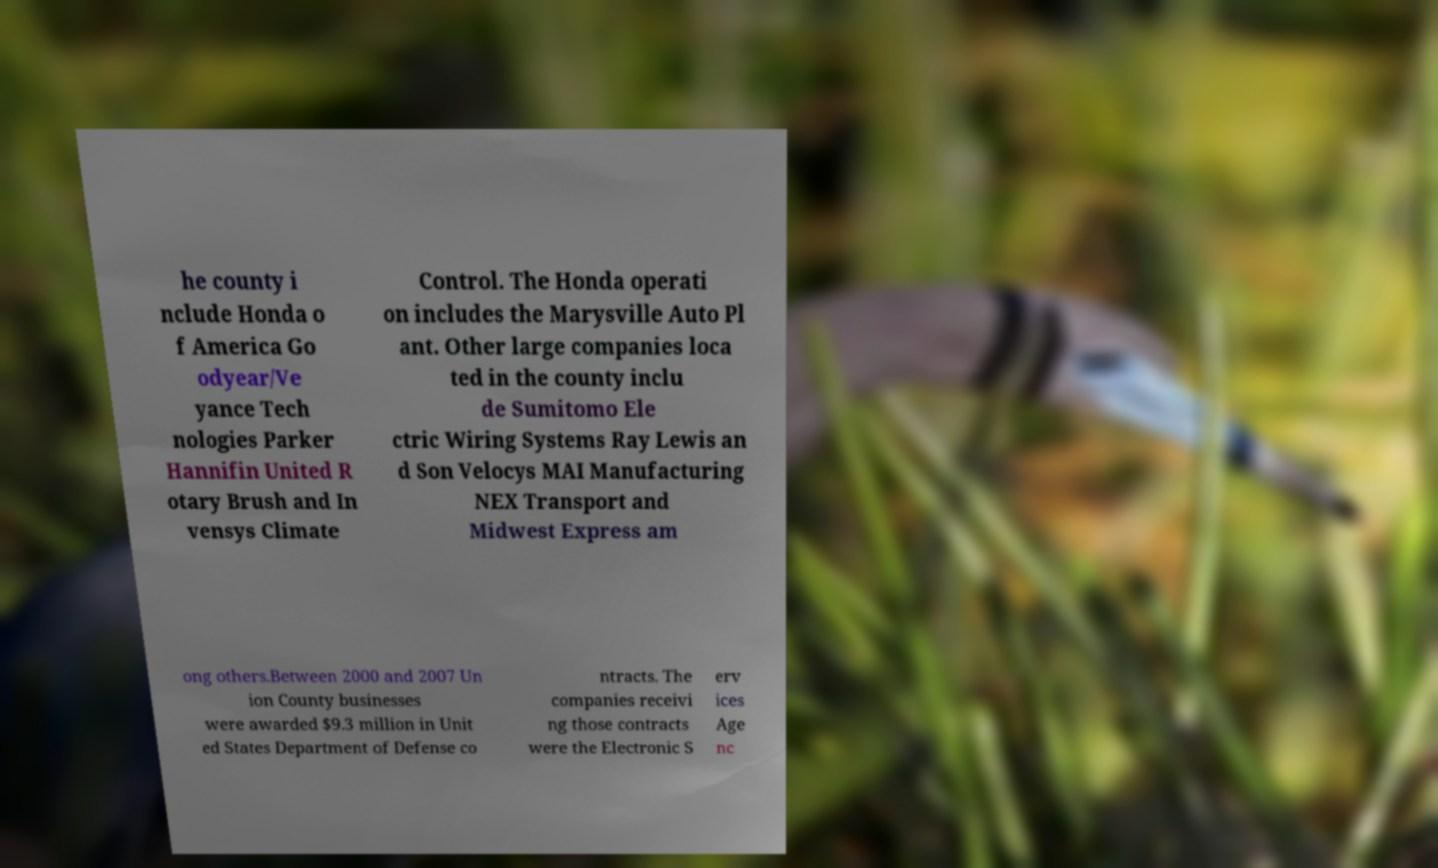For documentation purposes, I need the text within this image transcribed. Could you provide that? he county i nclude Honda o f America Go odyear/Ve yance Tech nologies Parker Hannifin United R otary Brush and In vensys Climate Control. The Honda operati on includes the Marysville Auto Pl ant. Other large companies loca ted in the county inclu de Sumitomo Ele ctric Wiring Systems Ray Lewis an d Son Velocys MAI Manufacturing NEX Transport and Midwest Express am ong others.Between 2000 and 2007 Un ion County businesses were awarded $9.3 million in Unit ed States Department of Defense co ntracts. The companies receivi ng those contracts were the Electronic S erv ices Age nc 